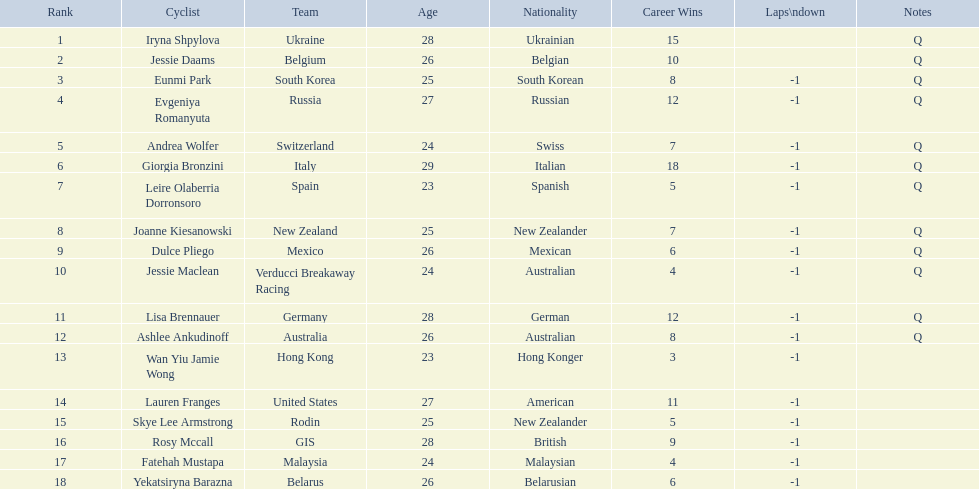Who are all the cyclists? Iryna Shpylova, Jessie Daams, Eunmi Park, Evgeniya Romanyuta, Andrea Wolfer, Giorgia Bronzini, Leire Olaberria Dorronsoro, Joanne Kiesanowski, Dulce Pliego, Jessie Maclean, Lisa Brennauer, Ashlee Ankudinoff, Wan Yiu Jamie Wong, Lauren Franges, Skye Lee Armstrong, Rosy Mccall, Fatehah Mustapa, Yekatsiryna Barazna. What were their ranks? 1, 2, 3, 4, 5, 6, 7, 8, 9, 10, 11, 12, 13, 14, 15, 16, 17, 18. Who was ranked highest? Iryna Shpylova. 